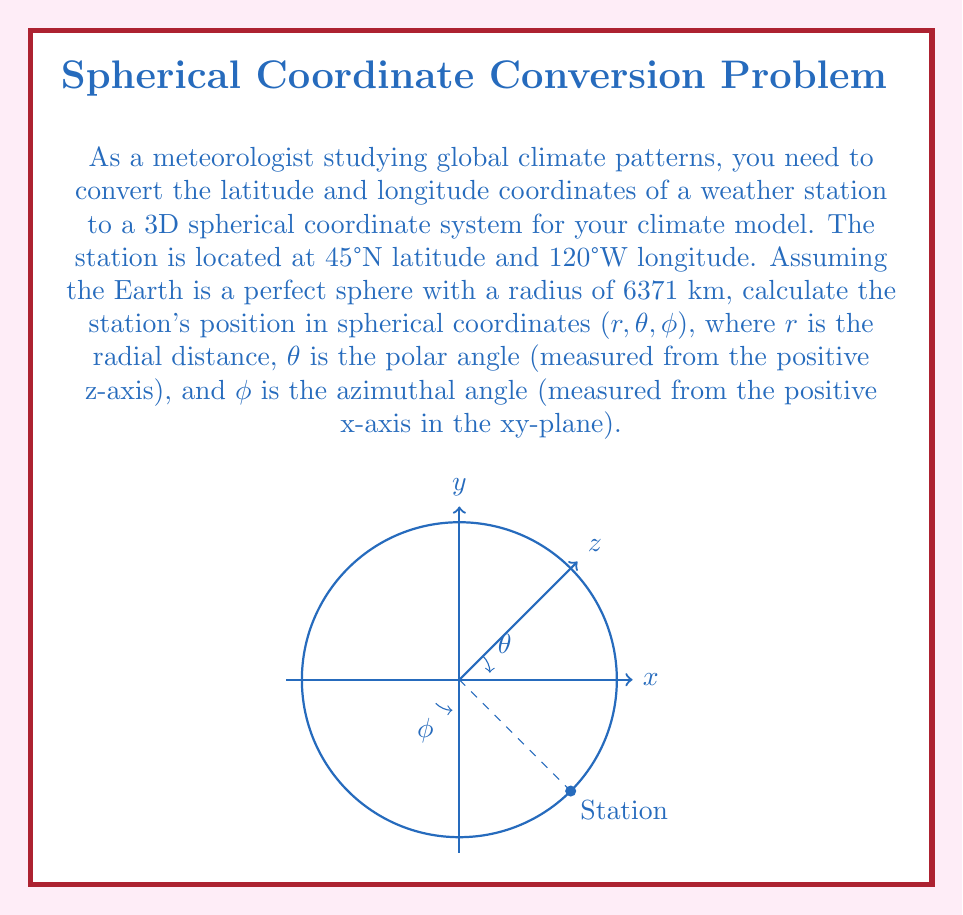Provide a solution to this math problem. Let's approach this step-by-step:

1) In the spherical coordinate system:
   - r: radial distance (distance from the center of the Earth)
   - θ: polar angle (90° - latitude)
   - φ: azimuthal angle (longitude + 180°)

2) For r:
   The radius of the Earth is given as 6371 km, so r = 6371 km.

3) For θ:
   θ = 90° - latitude
   θ = 90° - 45° = 45°
   Convert to radians: θ = 45° × (π/180°) = π/4 radians

4) For φ:
   φ = longitude + 180°
   φ = -120° + 180° = 60°
   Convert to radians: φ = 60° × (π/180°) = π/3 radians

5) Therefore, the spherical coordinates are:
   $$(r, θ, φ) = (6371, \frac{\pi}{4}, \frac{\pi}{3})$$

Note: It's common in geophysics to use latitude directly as the polar angle and longitude as the azimuthal angle. However, the question specifically asks for the standard mathematical convention of spherical coordinates, which is why we performed the conversions in steps 3 and 4.
Answer: $$(6371\text{ km}, \frac{\pi}{4}\text{ rad}, \frac{\pi}{3}\text{ rad})$$ 